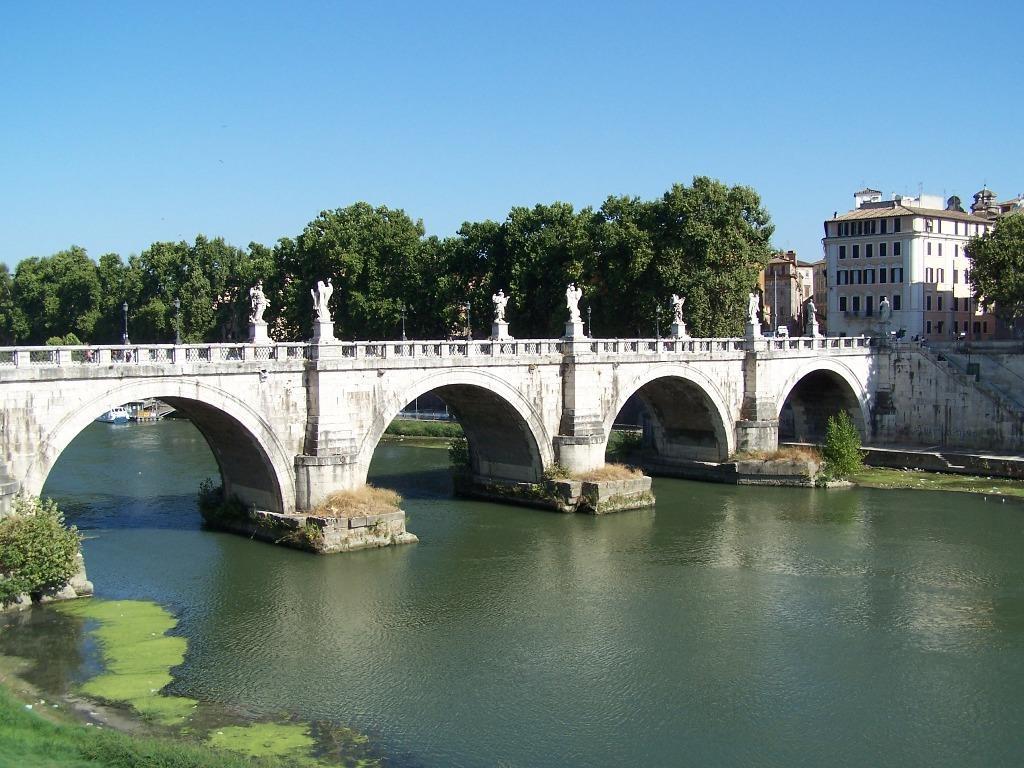Describe this image in one or two sentences. In this picture, we can see bridge, stairs, water and layer on the water, ground with grass, plants, trees, buildings with windows and the sky. 